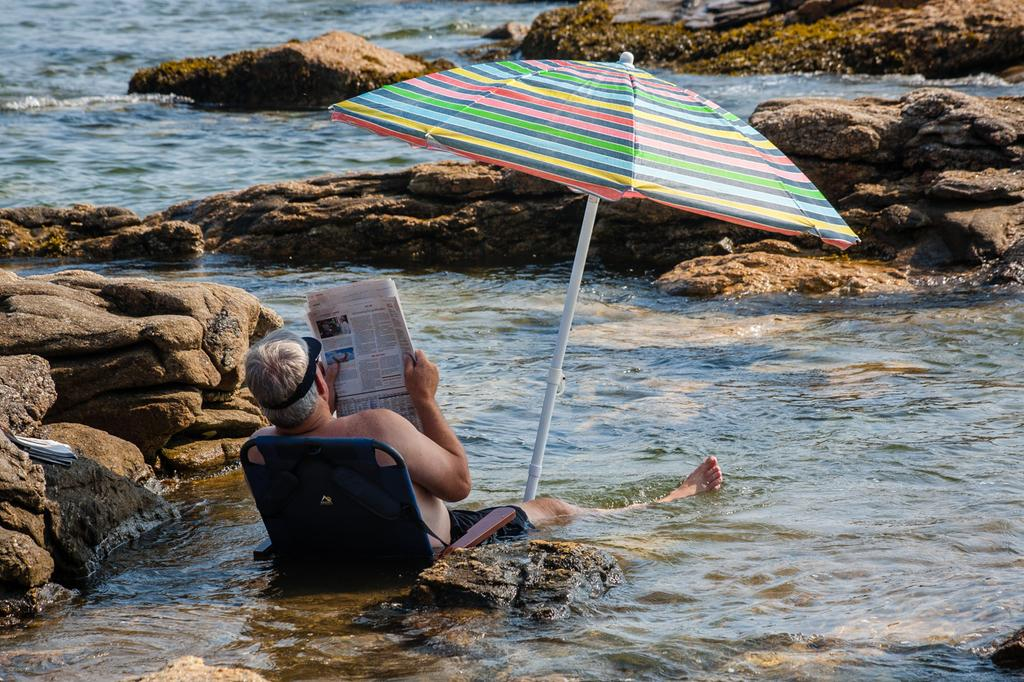What is the person in the image doing? The person is holding or reading a newspaper. Where is the person located in the image? The person is sitting in water, possibly a river or ocean. What object is visible in the image that might provide shade or protection from the elements? An umbrella is visible in the image. What type of environment is depicted in the image? There is water visible in the image, and a stony surface is present. What type of drain is visible in the image? There is no drain present in the image. What hope does the person have for their future while sitting in the water? The image does not provide any information about the person's hopes or future plans. 